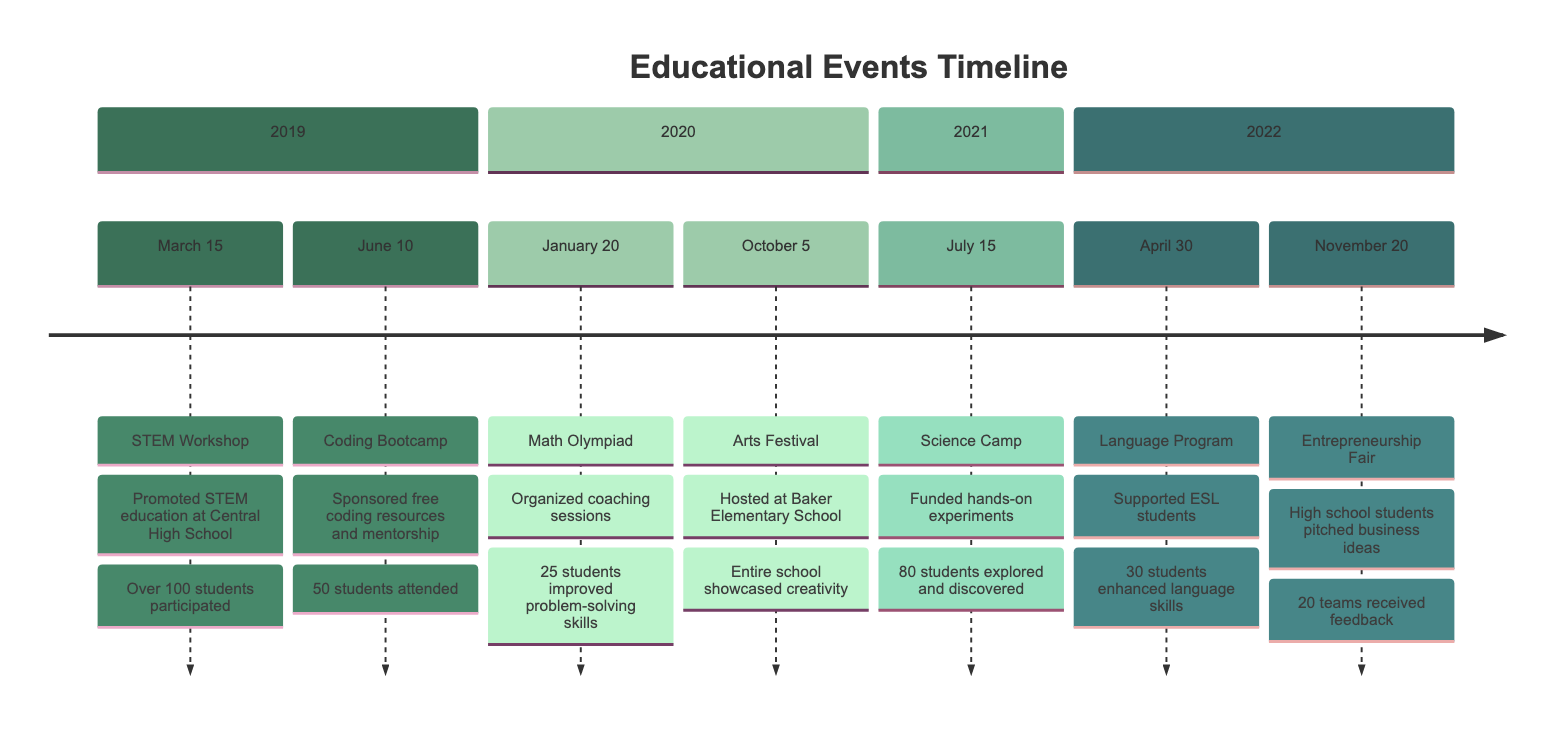What event occurred on March 15, 2019? The diagram indicates that the event on March 15, 2019, was a STEM Workshop. This is stated directly under the date in the timeline section for 2019.
Answer: STEM Workshop How many students participated in the Coding Bootcamp? The diagram specifies that the Coding Bootcamp, held on June 10, 2019, had 50 students attending. This number is explicitly mentioned under the event.
Answer: 50 Which teacher was involved in the Math Olympiad Coaching? According to the diagram, Dr. Elena Garcia is the teacher associated with the Math Olympiad Coaching on January 20, 2020. This information is presented clearly under the event.
Answer: Dr. Elena Garcia What was the focus of the event on July 15, 2021? The timeline shows that the focus of the event on July 15, 2021, was a Science Camp, which centered around hands-on scientific experiments and exploration. This is described in detail under the event section.
Answer: Science Camp How many teams participated in the Entrepreneurship Fair? The Entrepreneurship Fair, which occurred on November 20, 2022, saw participation from 20 teams. This is specifically noted in the event description on the timeline.
Answer: 20 teams What skill was enhanced for ESL students in April 2022? The diagram indicates that the Language Skills Enhancement Program supported ESL students, enhancing their language skills. This is explicitly mentioned under the event on April 30, 2022.
Answer: Language skills Which event showcased the entire school’s creativity? The Arts Festival hosted on October 5, 2020, showcased the creativity of the entire school. This information is clearly stated in the corresponding event section.
Answer: Arts Festival How many teachers participated in the Summer Science Camp? The timeline mentions that two teachers, Dr. Alan Turing and Ms. Paula White, were involved in the Summer Science Camp on July 15, 2021. This number is specified under the participants for that event.
Answer: 2 teachers What was a common theme across the 2019 events? Both events in 2019—STEM Workshop and Coding Bootcamp—focused on promoting STEM education and coding skills respectively, reflecting a common theme of technology and education enhancement for students. This comparison requires looking at the descriptions of both events.
Answer: Promotion of STEM education 